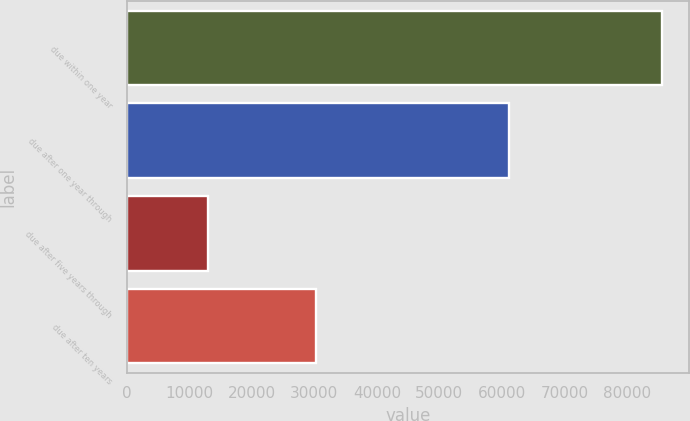Convert chart to OTSL. <chart><loc_0><loc_0><loc_500><loc_500><bar_chart><fcel>due within one year<fcel>due after one year through<fcel>due after five years through<fcel>due after ten years<nl><fcel>85654<fcel>61047<fcel>12963<fcel>30316<nl></chart> 